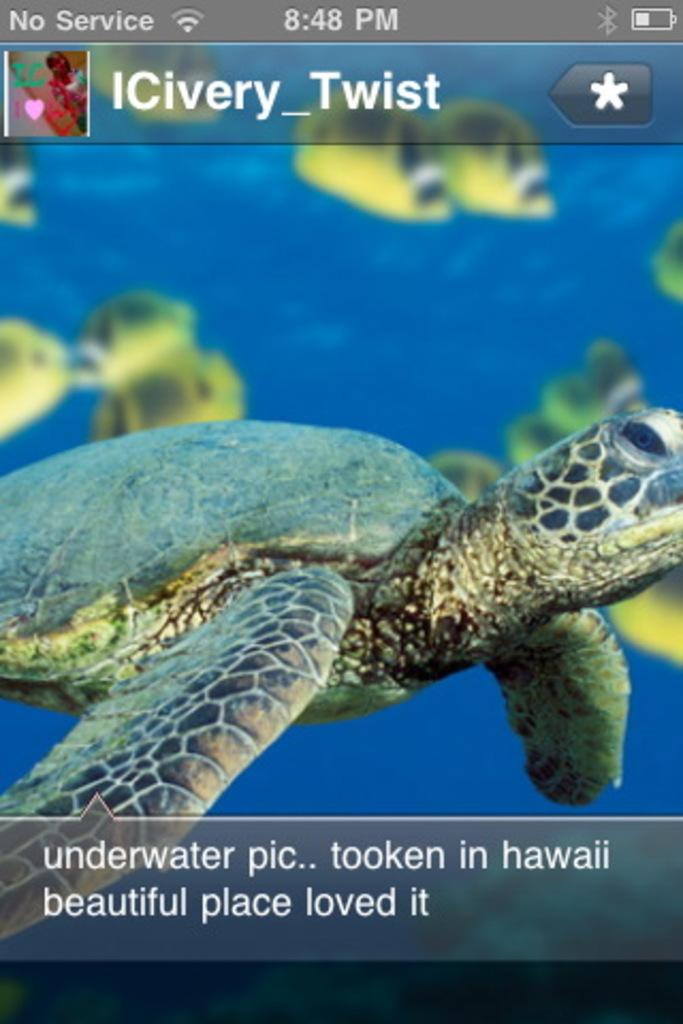What is the main object in the image that resembles a mobile screen? There is a screen that resembles a mobile screen in the image. What type of animal can be seen in the image? There is a tortoise in the image. What can be seen underwater in the image? There are fishes visible underwater in the image. What is displayed on the screen in the image? There are text and images on the screen. Is there a toothpaste tube being squeezed by a ghost in the image? No, there is no toothpaste tube or ghost present in the image. 